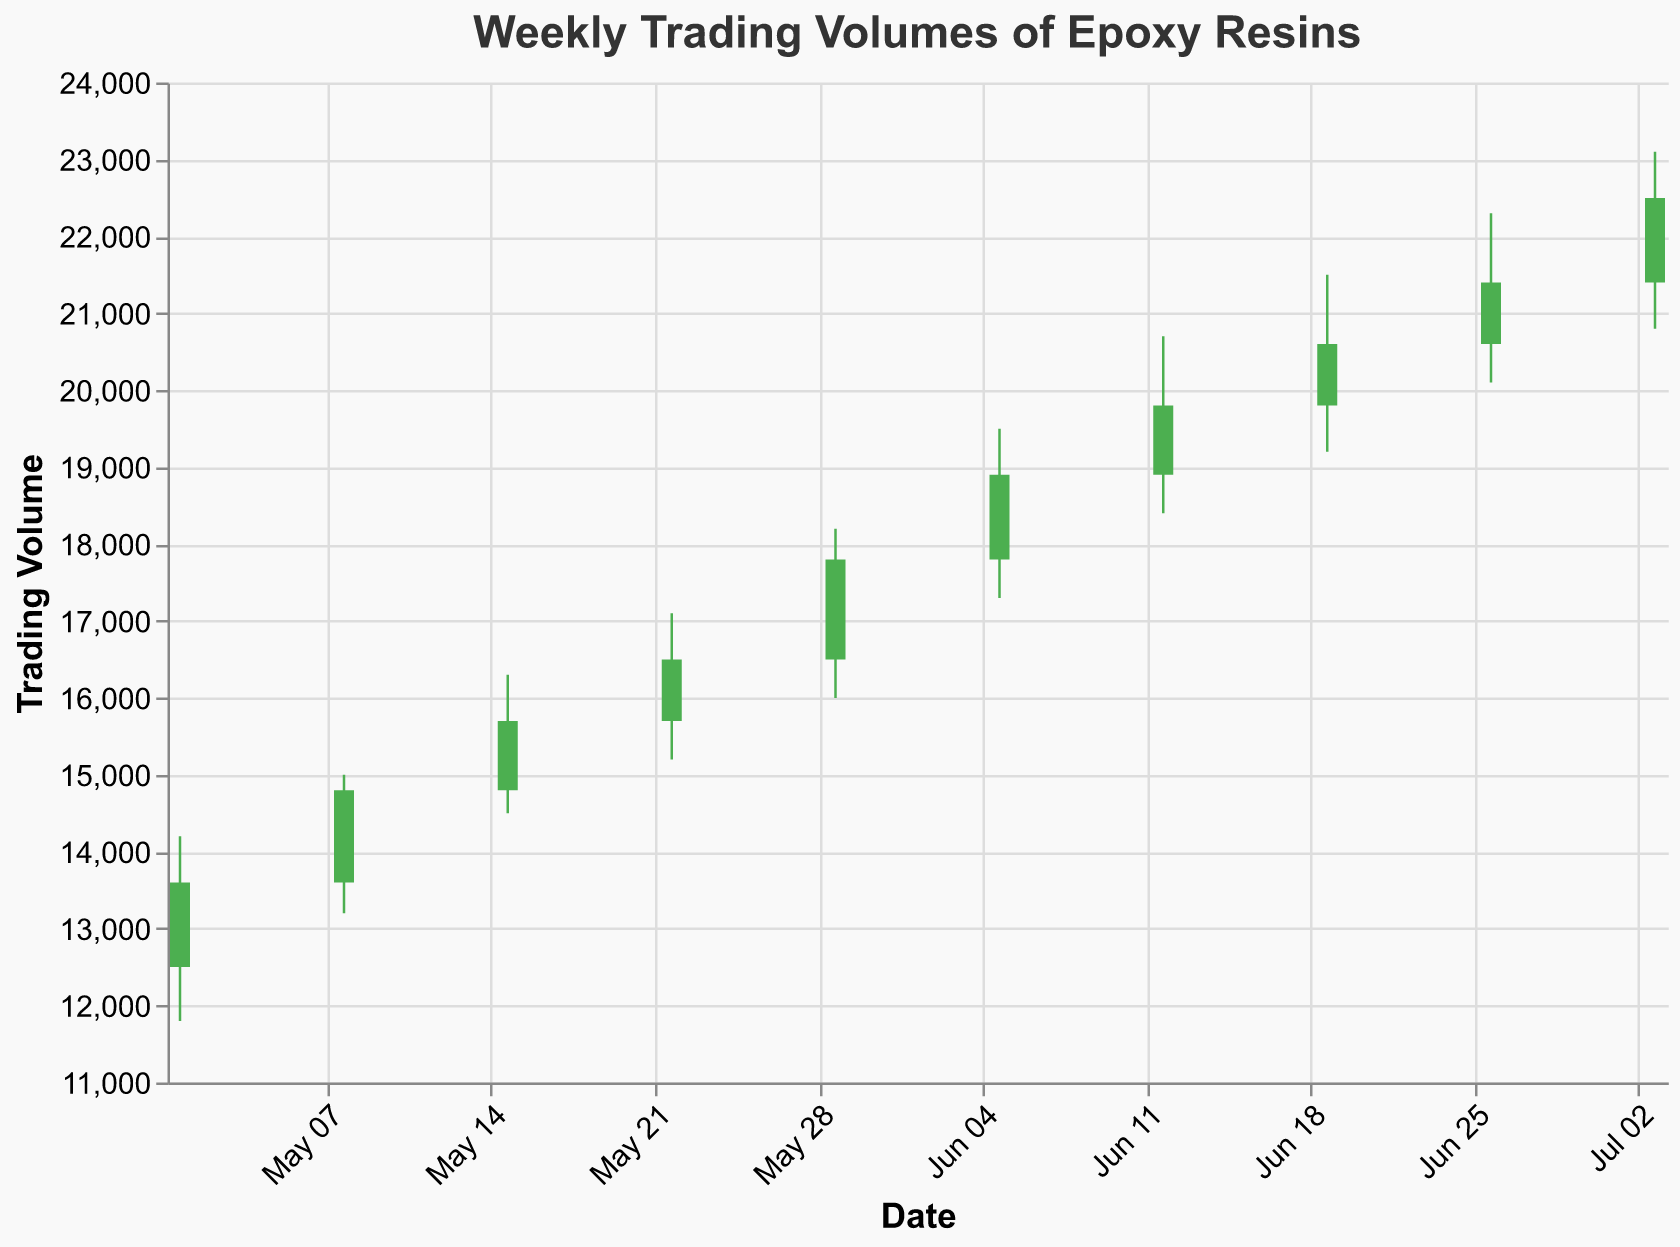What is the title of the chart? The title is the textual information at the top of the chart that describes its content and purpose.
Answer: Weekly Trading Volumes of Epoxy Resins How many data points are there in the chart? Each data point corresponds to a weekly record with Open, High, Low, and Close values. Counting these points gives the answer.
Answer: 10 Which week had the highest trading volume on close? Look for the highest 'Close' value in the chart data.
Answer: 2023-07-03 Did the trading volume increase or decrease from the week of 2023-06-26 to 2023-07-03? Compare the closing values of these two weeks to determine the trend. 21400 < 22500
Answer: Increase What is the opening trading volume of the week of 2023-06-19? Locate the 'Open' value for the specific date in the chart.
Answer: 19800 Which week shows the lowest 'Low' trading volume? Identify the week with the minimum 'Low' value from the data.
Answer: 2023-05-01 Calculate the average closing trading volume for the month of May 2023. Sum the 'Close' values for the weeks of May and divide by the number of weeks. May has 5 weeks: (13600 + 14800 + 15700 + 16500 + 17800) / 5 = 78400 / 5
Answer: 15680 Compare the highest trading volumes between May and June 2023. Which month has a higher max value? Extract the maximum 'High' values for May and June. May's max is 18200 and June's is 22300. Compare these values.
Answer: June For the week of 2023-06-05, was the closing trading volume higher or lower than the opening volume? Compare the 'Close' and 'Open' values for that specific week. 18900 > 17800
Answer: Higher What is the difference between the highest and lowest trading volumes observed in the week of 2023-06-12? Subtract the 'Low' value from the 'High' value for that week. 20700 - 18400
Answer: 2300 